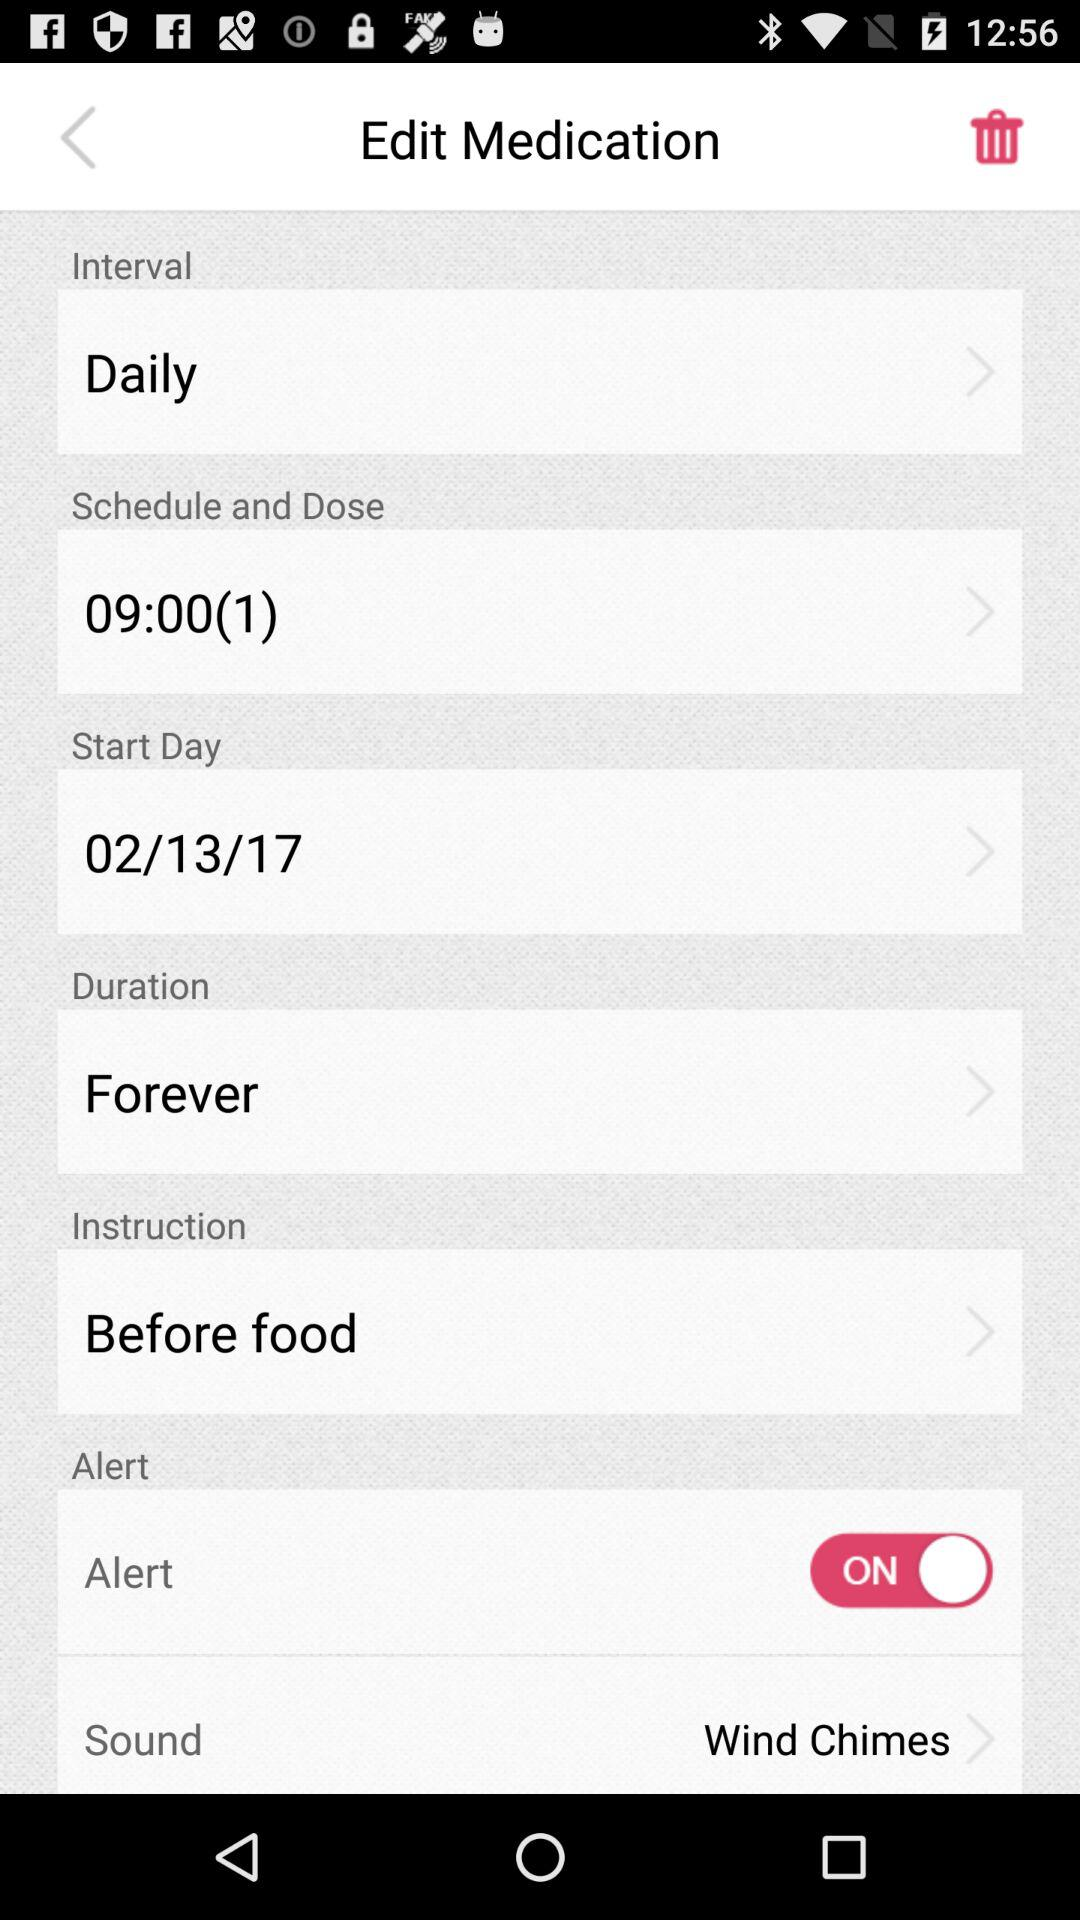Which is the selected "Duration"? The selected duration is "Forever". 